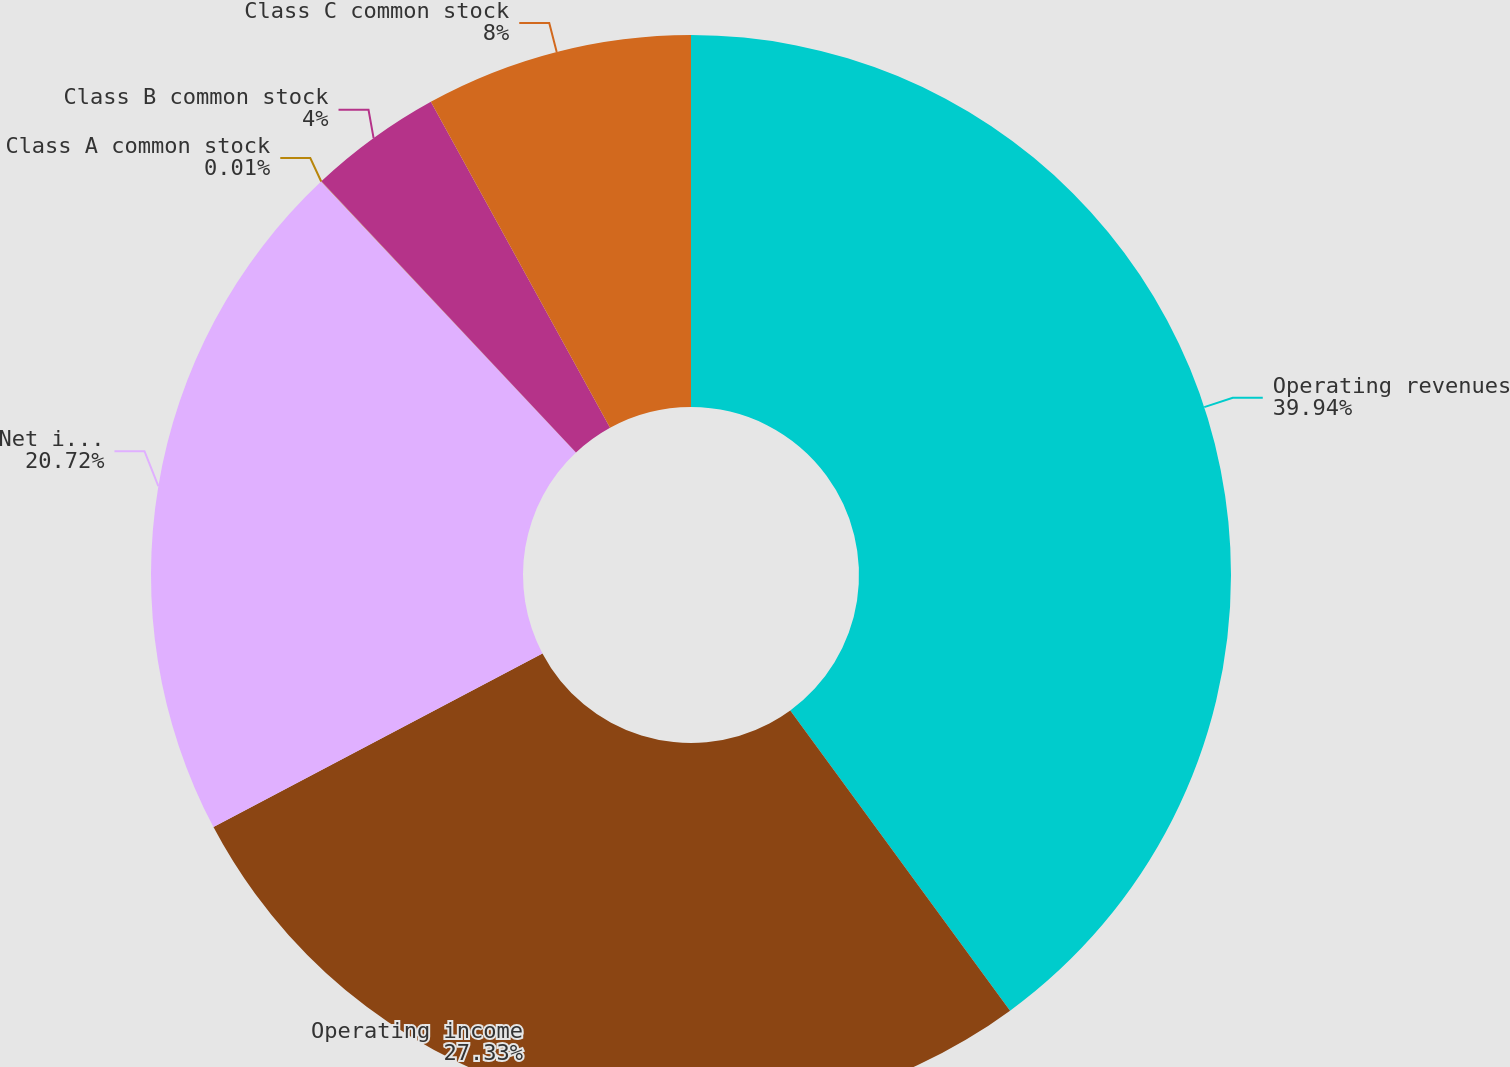Convert chart to OTSL. <chart><loc_0><loc_0><loc_500><loc_500><pie_chart><fcel>Operating revenues<fcel>Operating income<fcel>Net income<fcel>Class A common stock<fcel>Class B common stock<fcel>Class C common stock<nl><fcel>39.94%<fcel>27.33%<fcel>20.72%<fcel>0.01%<fcel>4.0%<fcel>8.0%<nl></chart> 